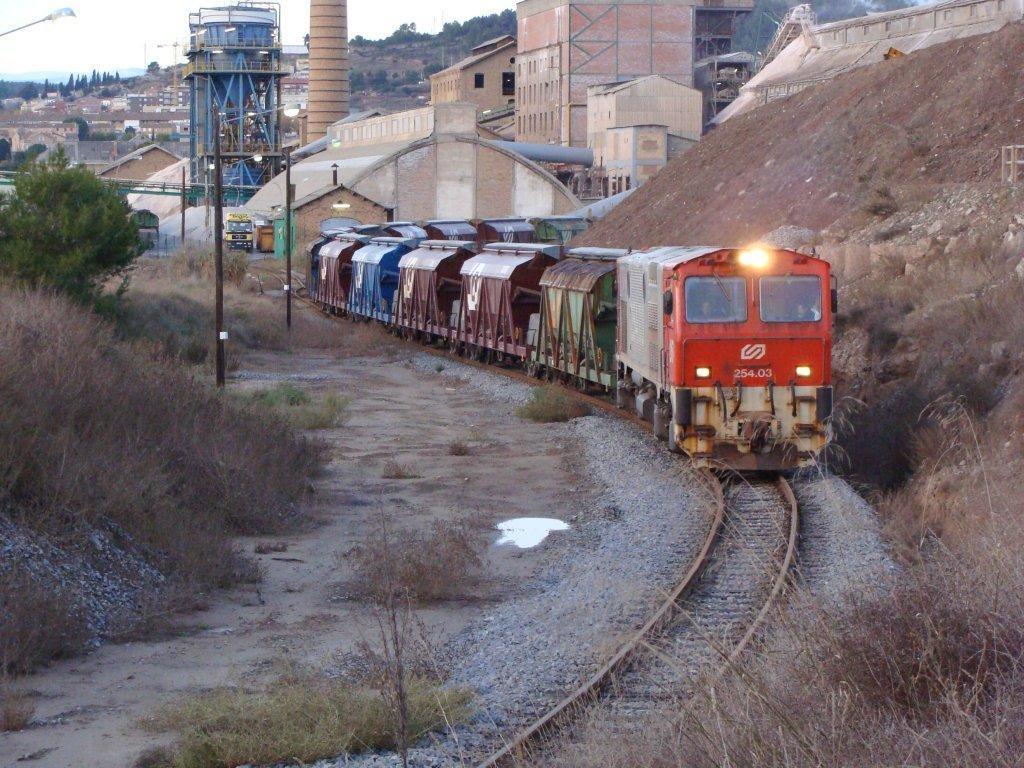How would you summarize this image in a sentence or two? In this image there is the sky towards the top of the image, there are trees, there are buildings, there are objects towards the top of the image, there are vehicles, there is a train, there is a railway track, there are stones on the ground, there are plants towards the left of the image, there are plants towards the bottom of the image, there are plants towards the bottom of the image, there is soil towards the right of the image, there is a pipe, there are poles. 